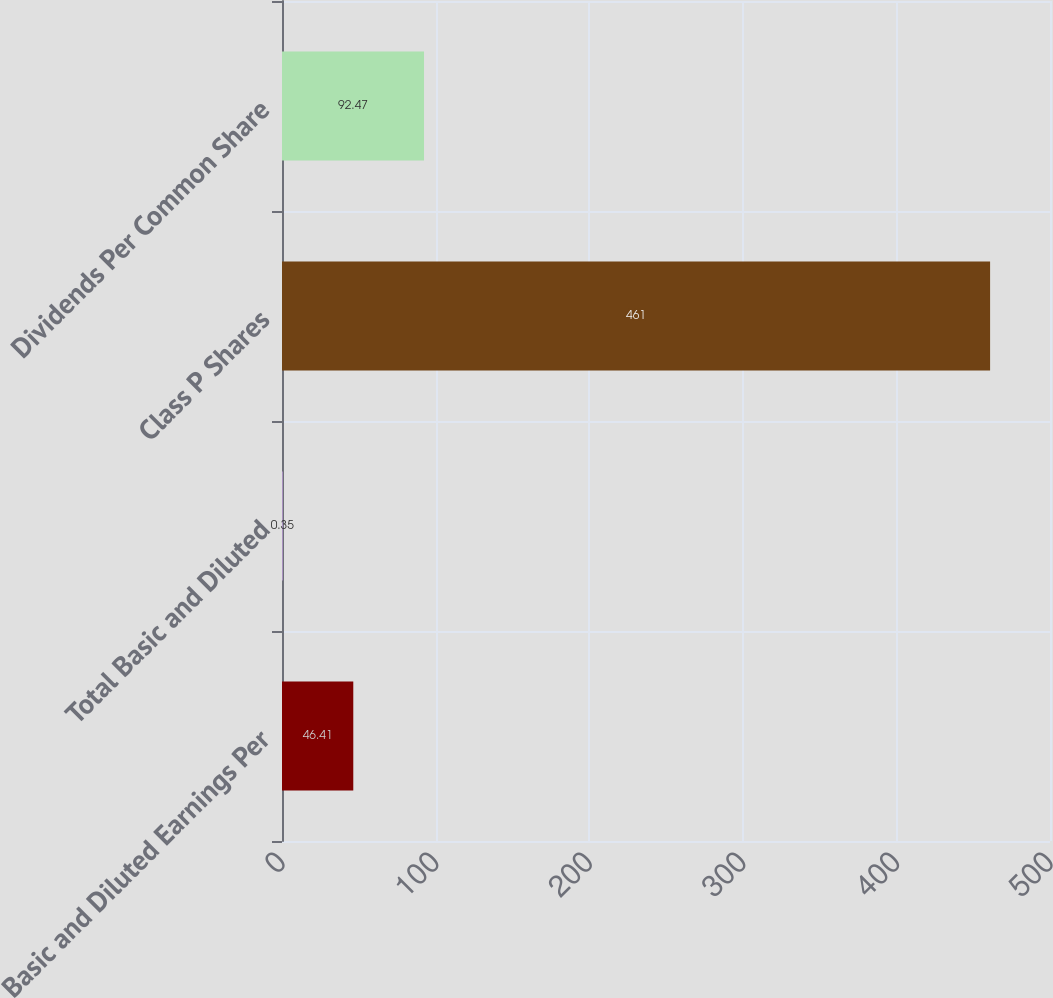Convert chart. <chart><loc_0><loc_0><loc_500><loc_500><bar_chart><fcel>Basic and Diluted Earnings Per<fcel>Total Basic and Diluted<fcel>Class P Shares<fcel>Dividends Per Common Share<nl><fcel>46.41<fcel>0.35<fcel>461<fcel>92.47<nl></chart> 